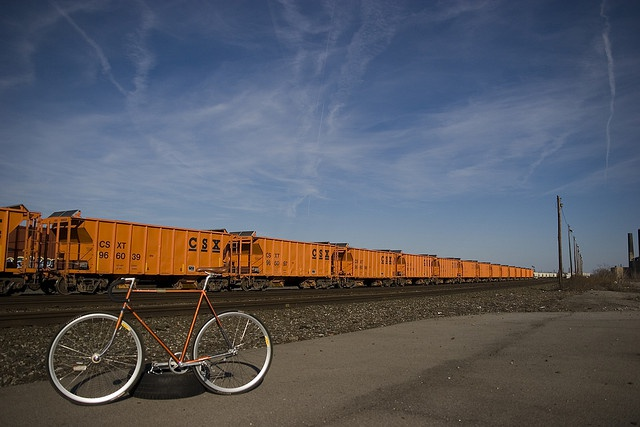Describe the objects in this image and their specific colors. I can see train in black, red, and maroon tones and bicycle in black and gray tones in this image. 